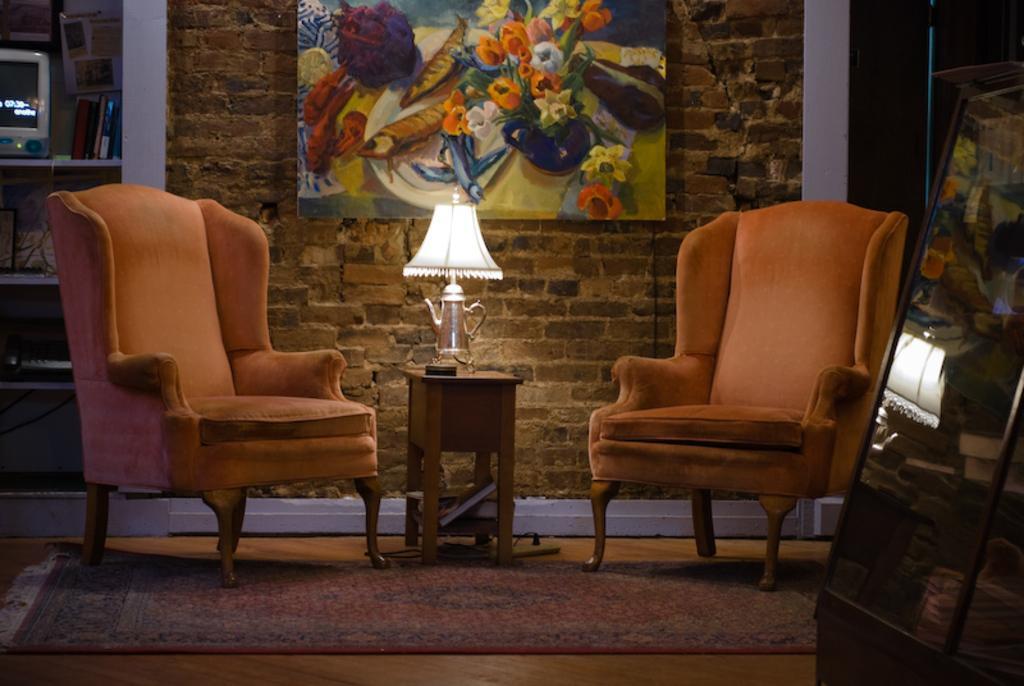Describe this image in one or two sentences. This picture is clicked inside the room. On the right corner we can see an object seems to be the cabinet. In the center we can see the chairs, lamp and some objects are placed on the top of the table. In the background we can see the wall, paintings of some objects hanging on the wall and we can see an electronic device, books and some other items in the background and we can see the floor mat. 